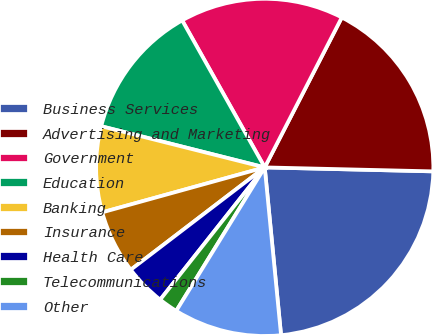<chart> <loc_0><loc_0><loc_500><loc_500><pie_chart><fcel>Business Services<fcel>Advertising and Marketing<fcel>Government<fcel>Education<fcel>Banking<fcel>Insurance<fcel>Health Care<fcel>Telecommunications<fcel>Other<nl><fcel>23.08%<fcel>17.82%<fcel>15.7%<fcel>12.93%<fcel>8.22%<fcel>6.09%<fcel>3.97%<fcel>1.85%<fcel>10.34%<nl></chart> 